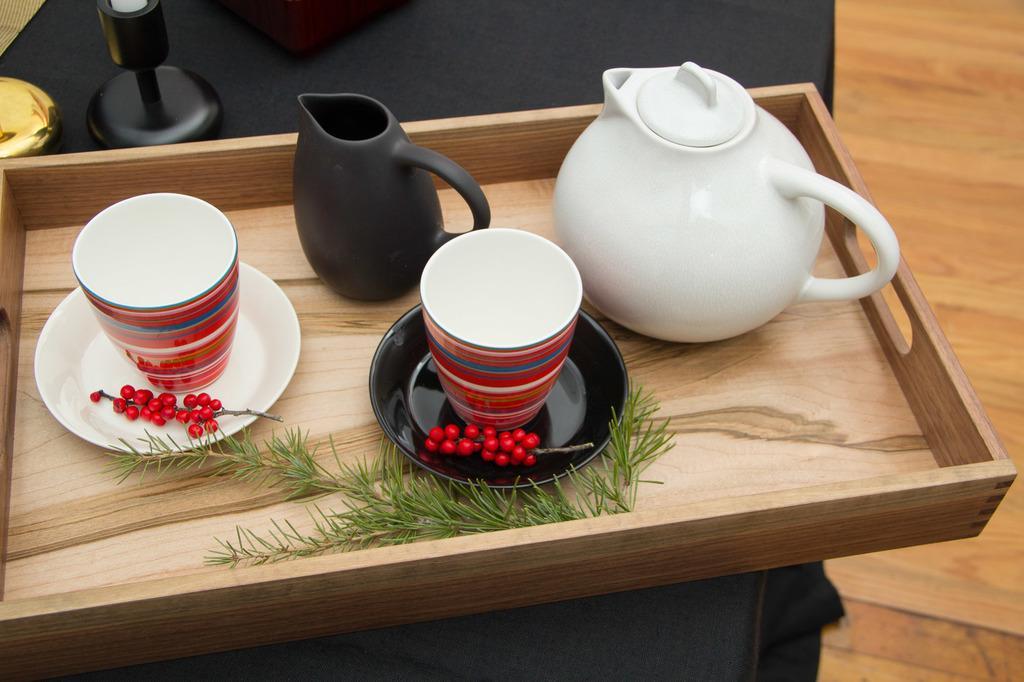Describe this image in one or two sentences. In this image we can see a black cloth. On that there is a black color object and wooden box. On the wooden box there is a stem, mugs and saucers. On the saucers there are cups and a decorative item. And the black cloth is on a wooden surface. 